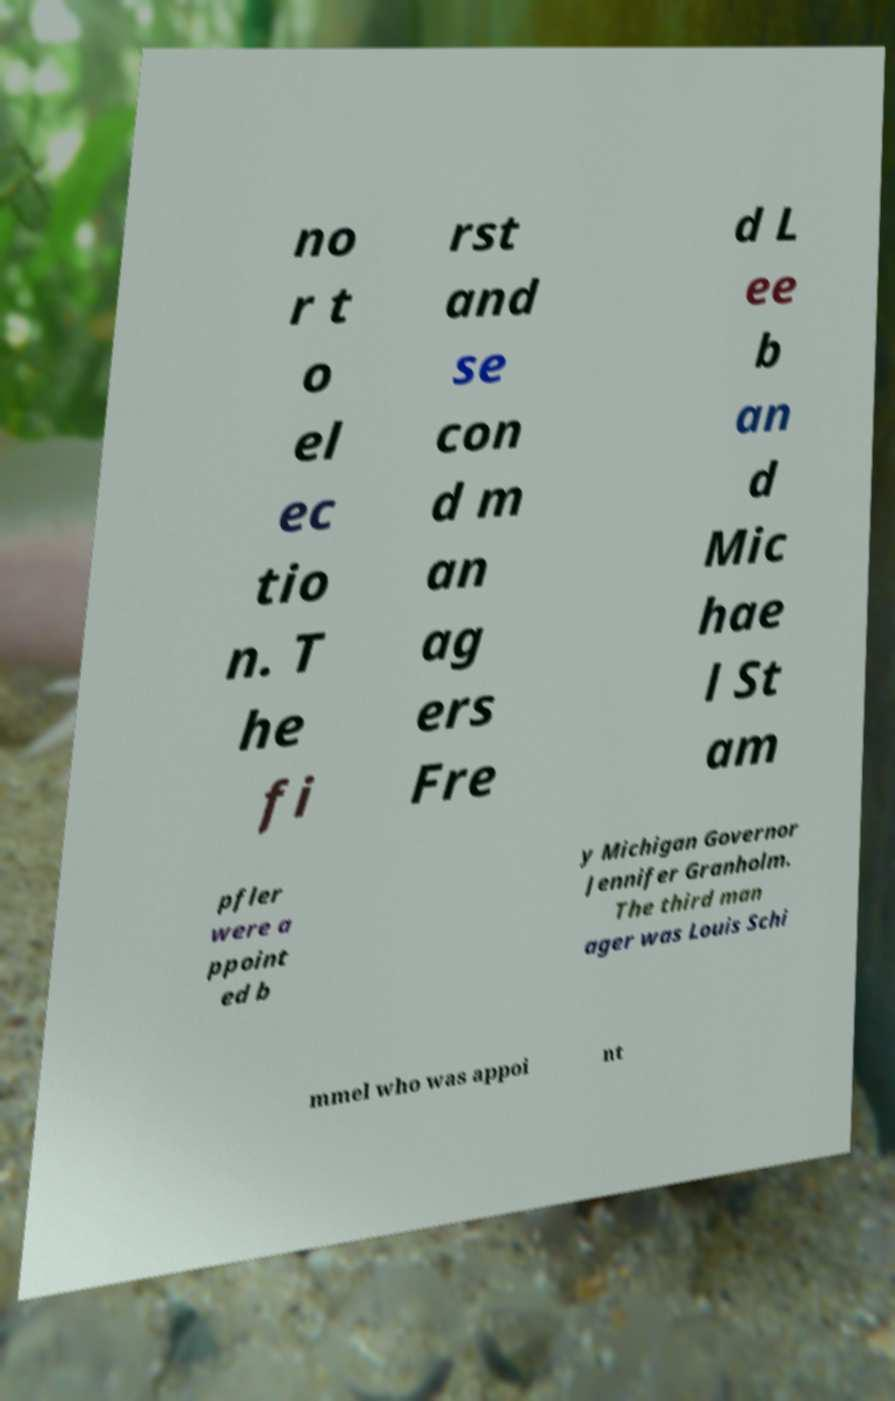For documentation purposes, I need the text within this image transcribed. Could you provide that? no r t o el ec tio n. T he fi rst and se con d m an ag ers Fre d L ee b an d Mic hae l St am pfler were a ppoint ed b y Michigan Governor Jennifer Granholm. The third man ager was Louis Schi mmel who was appoi nt 